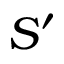Convert formula to latex. <formula><loc_0><loc_0><loc_500><loc_500>S ^ { \prime }</formula> 